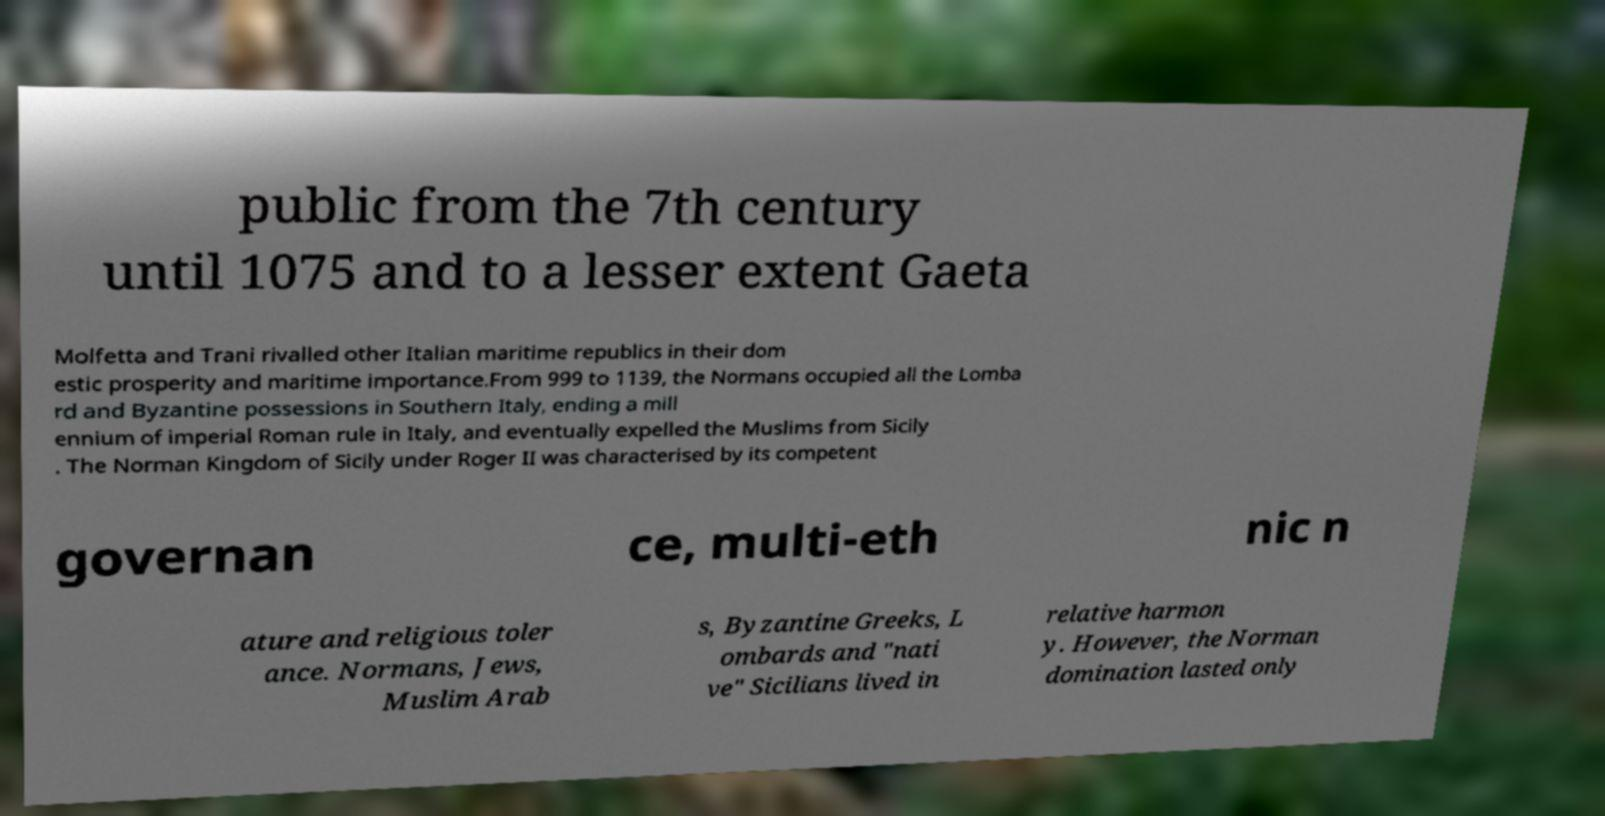For documentation purposes, I need the text within this image transcribed. Could you provide that? public from the 7th century until 1075 and to a lesser extent Gaeta Molfetta and Trani rivalled other Italian maritime republics in their dom estic prosperity and maritime importance.From 999 to 1139, the Normans occupied all the Lomba rd and Byzantine possessions in Southern Italy, ending a mill ennium of imperial Roman rule in Italy, and eventually expelled the Muslims from Sicily . The Norman Kingdom of Sicily under Roger II was characterised by its competent governan ce, multi-eth nic n ature and religious toler ance. Normans, Jews, Muslim Arab s, Byzantine Greeks, L ombards and "nati ve" Sicilians lived in relative harmon y. However, the Norman domination lasted only 